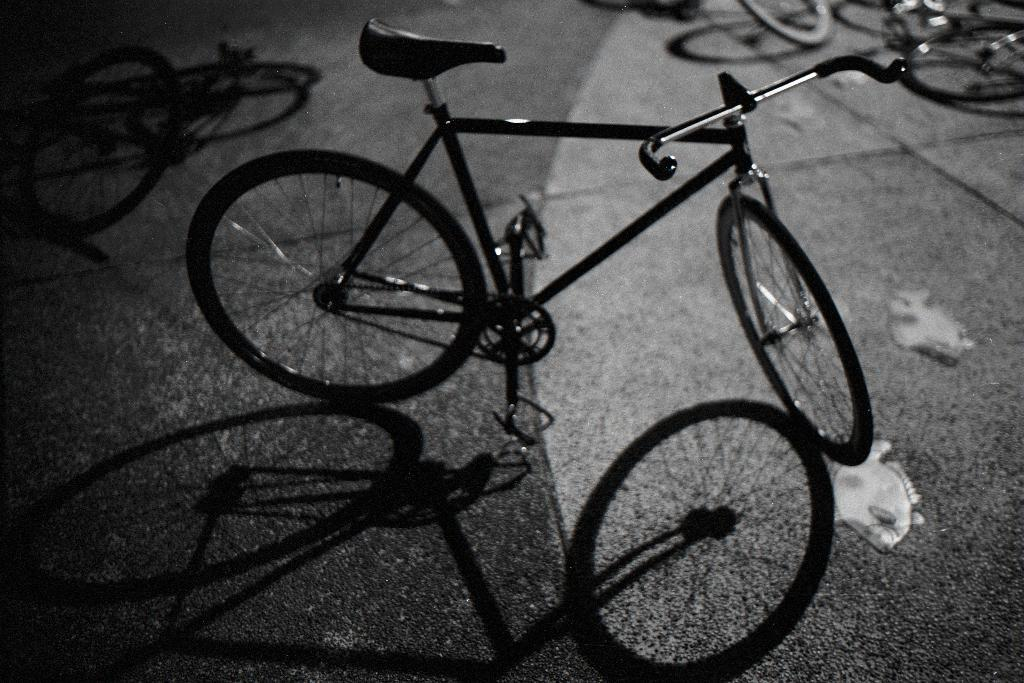What can be seen in the image? There are bicycles in the image. What else is visible at the bottom of the image? There is a shadow of a bicycle and tiles visible at the bottom of the image. What verse can be heard being recited by the bears in the image? There are no bears or verses present in the image. How many thumbs can be seen on the bicycles in the image? There are no thumbs visible on the bicycles in the image. 